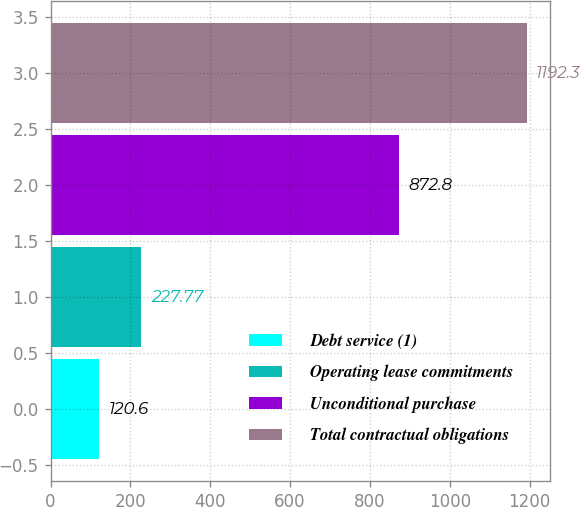<chart> <loc_0><loc_0><loc_500><loc_500><bar_chart><fcel>Debt service (1)<fcel>Operating lease commitments<fcel>Unconditional purchase<fcel>Total contractual obligations<nl><fcel>120.6<fcel>227.77<fcel>872.8<fcel>1192.3<nl></chart> 